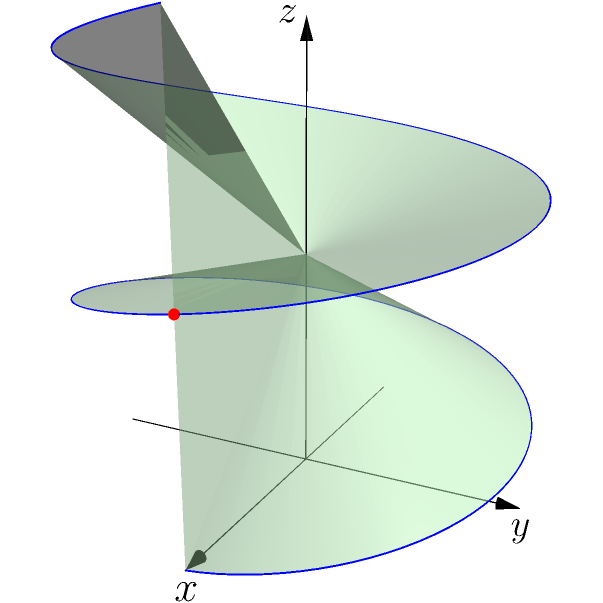During Mass, you observe the incense smoke rising from the thurible. The trajectory of the smoke can be modeled using the parametric equations:

$x = 2\cos(t)$
$y = 2\sin(t)$
$z = \frac{t}{2}$

Where $t$ represents time in seconds. At what point in time (in seconds) does the smoke reach a height of $\pi$ units above the thurible? To solve this problem, let's follow these steps:

1) We're looking for the point where the height (z-coordinate) equals $\pi$.

2) From the given equations, we know that $z = \frac{t}{2}$.

3) We can set up the equation:

   $\frac{t}{2} = \pi$

4) Multiply both sides by 2:

   $t = 2\pi$

5) This means that after $2\pi$ seconds, the smoke will reach a height of $\pi$ units.

6) We can verify this by plugging $t = 2\pi$ into the original equations:

   $x = 2\cos(2\pi) = 2$
   $y = 2\sin(2\pi) = 0$
   $z = \frac{2\pi}{2} = \pi$

   This point $(2, 0, \pi)$ is indeed $\pi$ units above the starting point $(2, 0, 0)$.

The red dot on the spiral in the diagram represents this point.
Answer: $2\pi$ seconds 